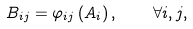Convert formula to latex. <formula><loc_0><loc_0><loc_500><loc_500>B _ { i j } = \varphi _ { i j } \left ( A _ { i } \right ) , \quad \forall i , j ,</formula> 